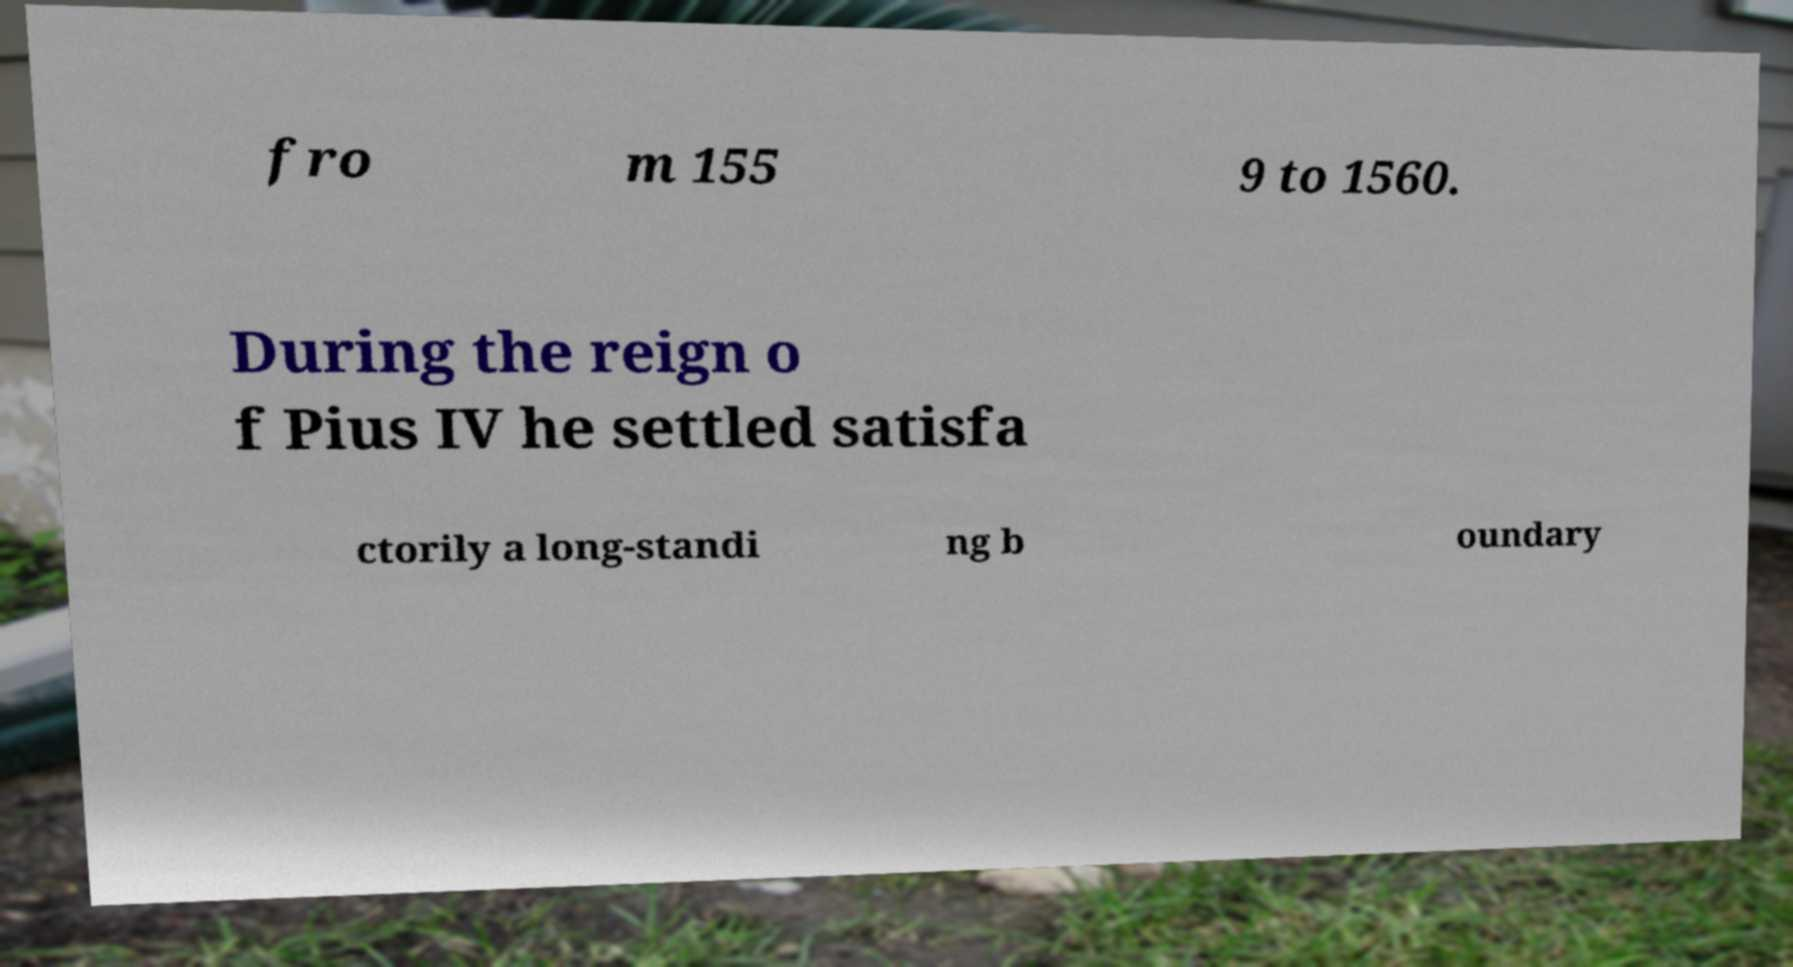What messages or text are displayed in this image? I need them in a readable, typed format. fro m 155 9 to 1560. During the reign o f Pius IV he settled satisfa ctorily a long-standi ng b oundary 